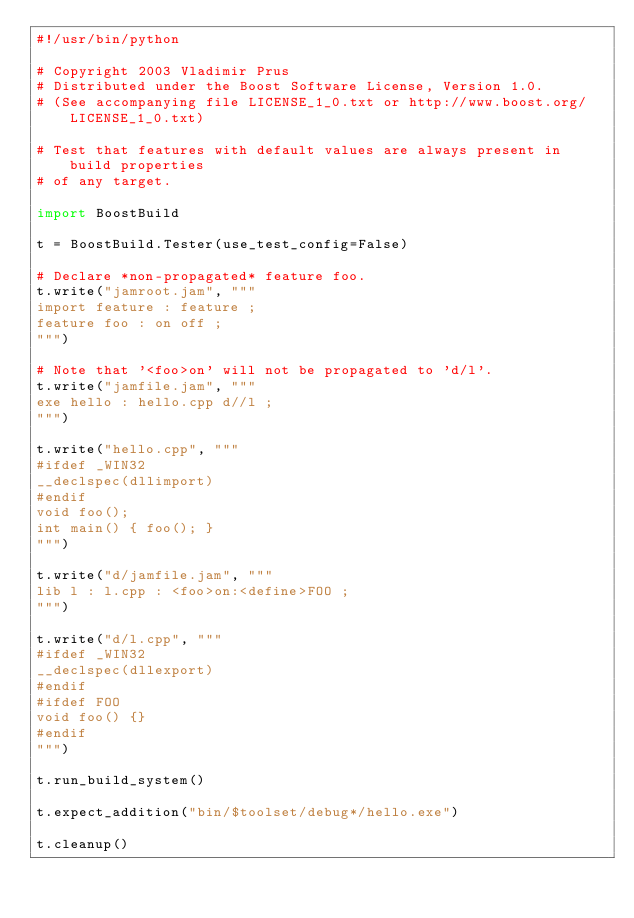Convert code to text. <code><loc_0><loc_0><loc_500><loc_500><_Python_>#!/usr/bin/python

# Copyright 2003 Vladimir Prus
# Distributed under the Boost Software License, Version 1.0.
# (See accompanying file LICENSE_1_0.txt or http://www.boost.org/LICENSE_1_0.txt)

# Test that features with default values are always present in build properties
# of any target.

import BoostBuild

t = BoostBuild.Tester(use_test_config=False)

# Declare *non-propagated* feature foo.
t.write("jamroot.jam", """
import feature : feature ;
feature foo : on off ;
""")

# Note that '<foo>on' will not be propagated to 'd/l'.
t.write("jamfile.jam", """
exe hello : hello.cpp d//l ;
""")

t.write("hello.cpp", """
#ifdef _WIN32
__declspec(dllimport)
#endif
void foo();
int main() { foo(); }
""")

t.write("d/jamfile.jam", """
lib l : l.cpp : <foo>on:<define>FOO ;
""")

t.write("d/l.cpp", """
#ifdef _WIN32
__declspec(dllexport)
#endif
#ifdef FOO
void foo() {}
#endif
""")

t.run_build_system()

t.expect_addition("bin/$toolset/debug*/hello.exe")

t.cleanup()
</code> 